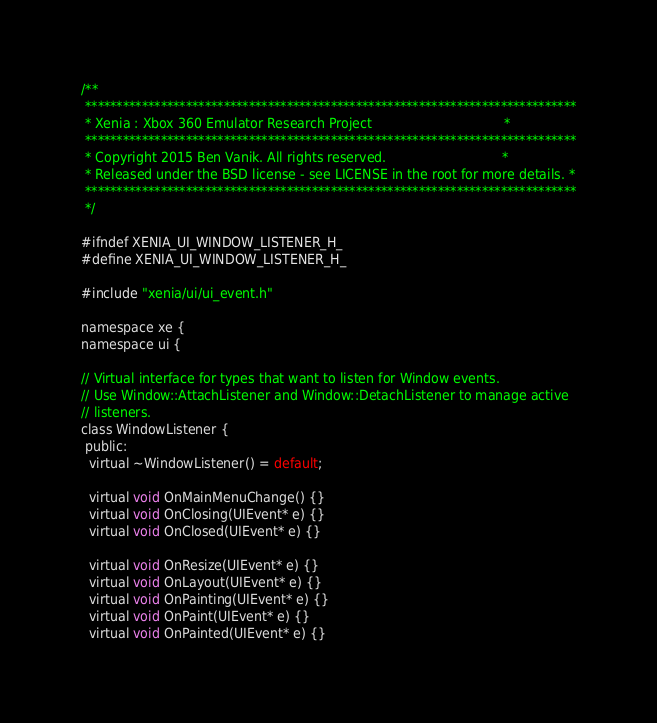<code> <loc_0><loc_0><loc_500><loc_500><_C_>/**
 ******************************************************************************
 * Xenia : Xbox 360 Emulator Research Project                                 *
 ******************************************************************************
 * Copyright 2015 Ben Vanik. All rights reserved.                             *
 * Released under the BSD license - see LICENSE in the root for more details. *
 ******************************************************************************
 */

#ifndef XENIA_UI_WINDOW_LISTENER_H_
#define XENIA_UI_WINDOW_LISTENER_H_

#include "xenia/ui/ui_event.h"

namespace xe {
namespace ui {

// Virtual interface for types that want to listen for Window events.
// Use Window::AttachListener and Window::DetachListener to manage active
// listeners.
class WindowListener {
 public:
  virtual ~WindowListener() = default;

  virtual void OnMainMenuChange() {}
  virtual void OnClosing(UIEvent* e) {}
  virtual void OnClosed(UIEvent* e) {}

  virtual void OnResize(UIEvent* e) {}
  virtual void OnLayout(UIEvent* e) {}
  virtual void OnPainting(UIEvent* e) {}
  virtual void OnPaint(UIEvent* e) {}
  virtual void OnPainted(UIEvent* e) {}</code> 